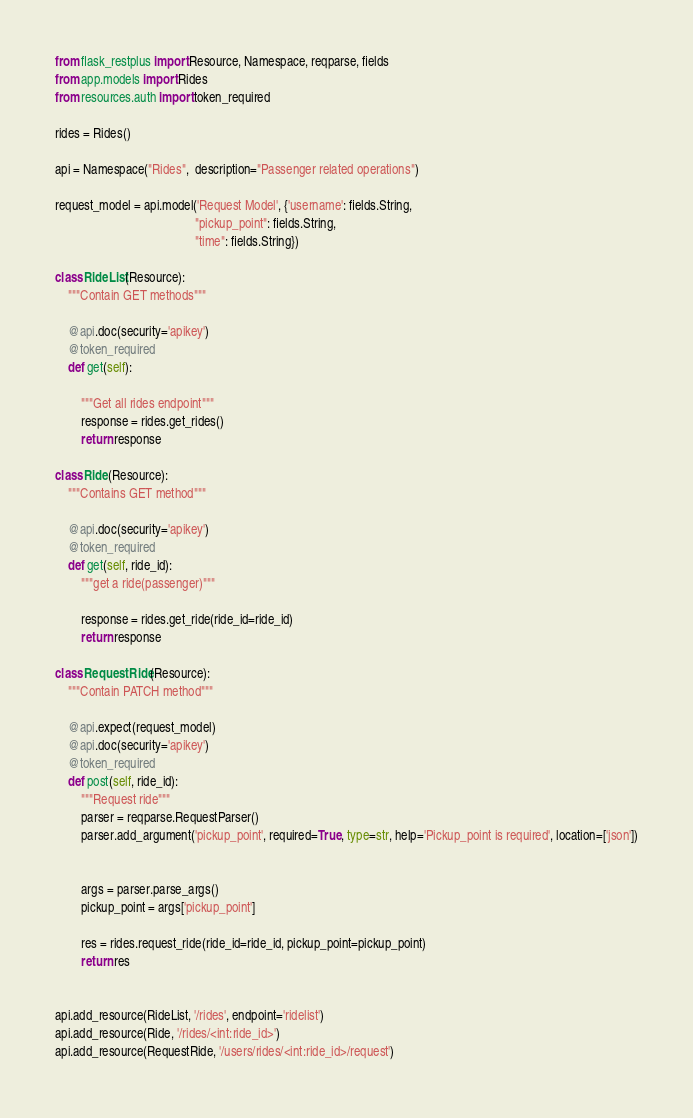<code> <loc_0><loc_0><loc_500><loc_500><_Python_>from flask_restplus import Resource, Namespace, reqparse, fields
from app.models import Rides
from resources.auth import token_required

rides = Rides()

api = Namespace("Rides",  description="Passenger related operations")

request_model = api.model('Request Model', {'username': fields.String,
                                            "pickup_point": fields.String,
                                            "time": fields.String})

class RideList(Resource):
    """Contain GET methods"""

    @api.doc(security='apikey')
    @token_required
    def get(self):

        """Get all rides endpoint"""
        response = rides.get_rides()
        return response

class Ride(Resource):
    """Contains GET method"""

    @api.doc(security='apikey')
    @token_required
    def get(self, ride_id):
        """get a ride(passenger)"""

        response = rides.get_ride(ride_id=ride_id)
        return response

class RequestRide(Resource):
    """Contain PATCH method"""

    @api.expect(request_model)
    @api.doc(security='apikey')
    @token_required
    def post(self, ride_id):
        """Request ride"""
        parser = reqparse.RequestParser()
        parser.add_argument('pickup_point', required=True, type=str, help='Pickup_point is required', location=['json'])


        args = parser.parse_args()
        pickup_point = args['pickup_point']

        res = rides.request_ride(ride_id=ride_id, pickup_point=pickup_point)
        return res


api.add_resource(RideList, '/rides', endpoint='ridelist')
api.add_resource(Ride, '/rides/<int:ride_id>')
api.add_resource(RequestRide, '/users/rides/<int:ride_id>/request')

</code> 